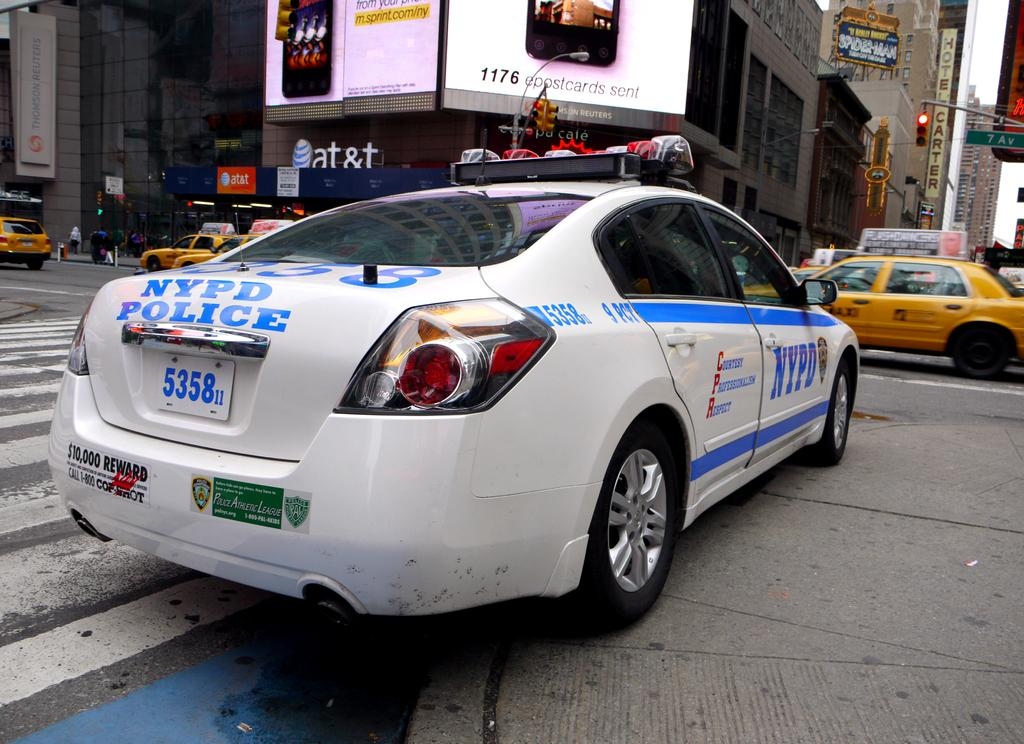Provide a one-sentence caption for the provided image. A white NYPD Police car sitting at a red stoplight. 